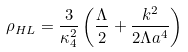Convert formula to latex. <formula><loc_0><loc_0><loc_500><loc_500>\rho _ { H L } = \frac { 3 } { \kappa _ { 4 } ^ { 2 } } \left ( \frac { \Lambda } 2 + \frac { k ^ { 2 } } { 2 \Lambda a ^ { 4 } } \right )</formula> 